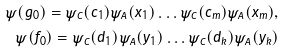Convert formula to latex. <formula><loc_0><loc_0><loc_500><loc_500>\psi ( g _ { 0 } ) = \psi _ { C } ( c _ { 1 } ) \psi _ { A } ( x _ { 1 } ) \dots \psi _ { C } ( c _ { m } ) \psi _ { A } ( x _ { m } ) , \\ \psi ( f _ { 0 } ) = \psi _ { C } ( d _ { 1 } ) \psi _ { A } ( y _ { 1 } ) \dots \psi _ { C } ( d _ { k } ) \psi _ { A } ( y _ { k } )</formula> 